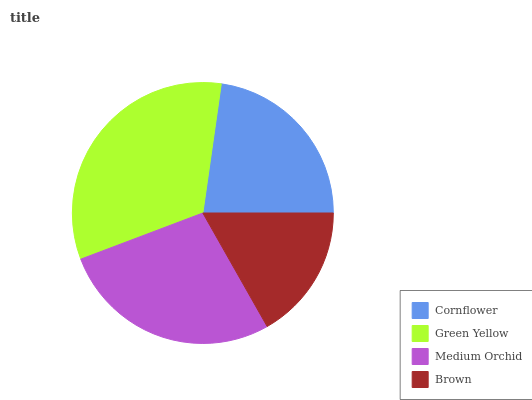Is Brown the minimum?
Answer yes or no. Yes. Is Green Yellow the maximum?
Answer yes or no. Yes. Is Medium Orchid the minimum?
Answer yes or no. No. Is Medium Orchid the maximum?
Answer yes or no. No. Is Green Yellow greater than Medium Orchid?
Answer yes or no. Yes. Is Medium Orchid less than Green Yellow?
Answer yes or no. Yes. Is Medium Orchid greater than Green Yellow?
Answer yes or no. No. Is Green Yellow less than Medium Orchid?
Answer yes or no. No. Is Medium Orchid the high median?
Answer yes or no. Yes. Is Cornflower the low median?
Answer yes or no. Yes. Is Brown the high median?
Answer yes or no. No. Is Medium Orchid the low median?
Answer yes or no. No. 